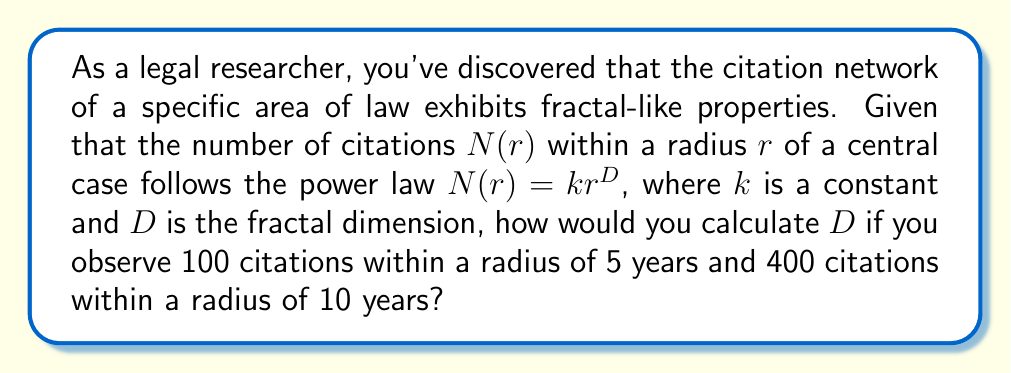Provide a solution to this math problem. To calculate the fractal dimension $D$, we'll use the given power law relationship and the two data points provided. Let's approach this step-by-step:

1) The power law relationship is given by:
   $$N(r) = kr^D$$

2) We have two data points:
   a) $N(5) = 100$
   b) $N(10) = 400$

3) Let's write equations for both data points:
   $$100 = k(5)^D$$
   $$400 = k(10)^D$$

4) Divide the second equation by the first:
   $$\frac{400}{100} = \frac{k(10)^D}{k(5)^D}$$

5) The $k$ cancels out:
   $$4 = \left(\frac{10}{5}\right)^D = 2^D$$

6) Take the logarithm (base 2) of both sides:
   $$\log_2(4) = \log_2(2^D)$$

7) Simplify:
   $$2 = D$$

Therefore, the fractal dimension $D$ of this citation network is 2.

This result indicates that the citation network grows in a way that fills a two-dimensional space, suggesting a complex but not overly dense interconnection of legal precedents.
Answer: $D = 2$ 